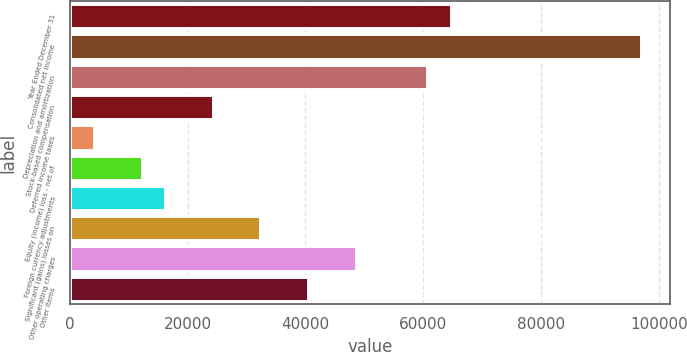Convert chart to OTSL. <chart><loc_0><loc_0><loc_500><loc_500><bar_chart><fcel>Year Ended December 31<fcel>Consolidated net income<fcel>Depreciation and amortization<fcel>Stock-based compensation<fcel>Deferred income taxes<fcel>Equity (income) loss - net of<fcel>Foreign currency adjustments<fcel>Significant (gains) losses on<fcel>Other operating charges<fcel>Other items<nl><fcel>64670.4<fcel>96985.6<fcel>60631<fcel>24276.4<fcel>4079.4<fcel>12158.2<fcel>16197.6<fcel>32355.2<fcel>48512.8<fcel>40434<nl></chart> 